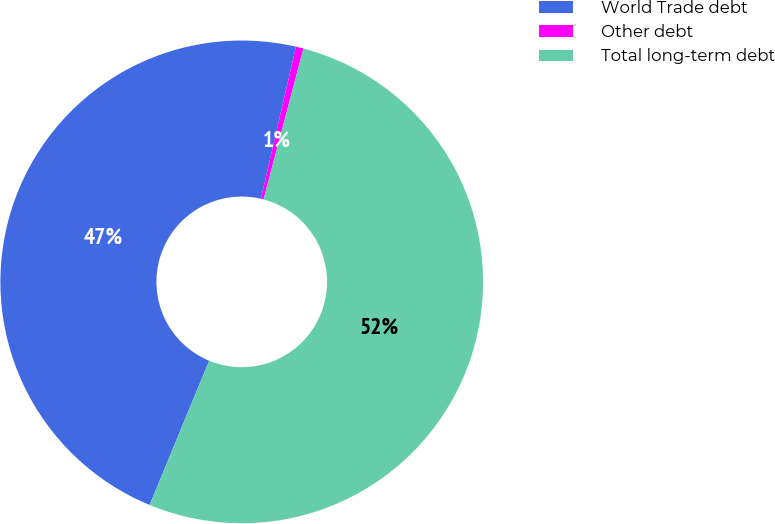Convert chart to OTSL. <chart><loc_0><loc_0><loc_500><loc_500><pie_chart><fcel>World Trade debt<fcel>Other debt<fcel>Total long-term debt<nl><fcel>47.38%<fcel>0.51%<fcel>52.12%<nl></chart> 